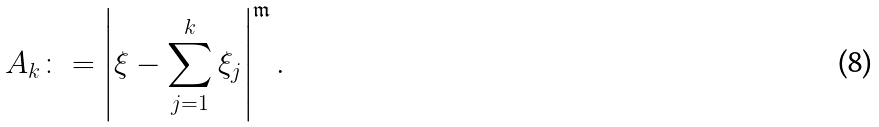Convert formula to latex. <formula><loc_0><loc_0><loc_500><loc_500>A _ { k } \colon = \left | \xi - \sum _ { j = 1 } ^ { k } \xi _ { j } \right | ^ { \mathfrak { m } } .</formula> 